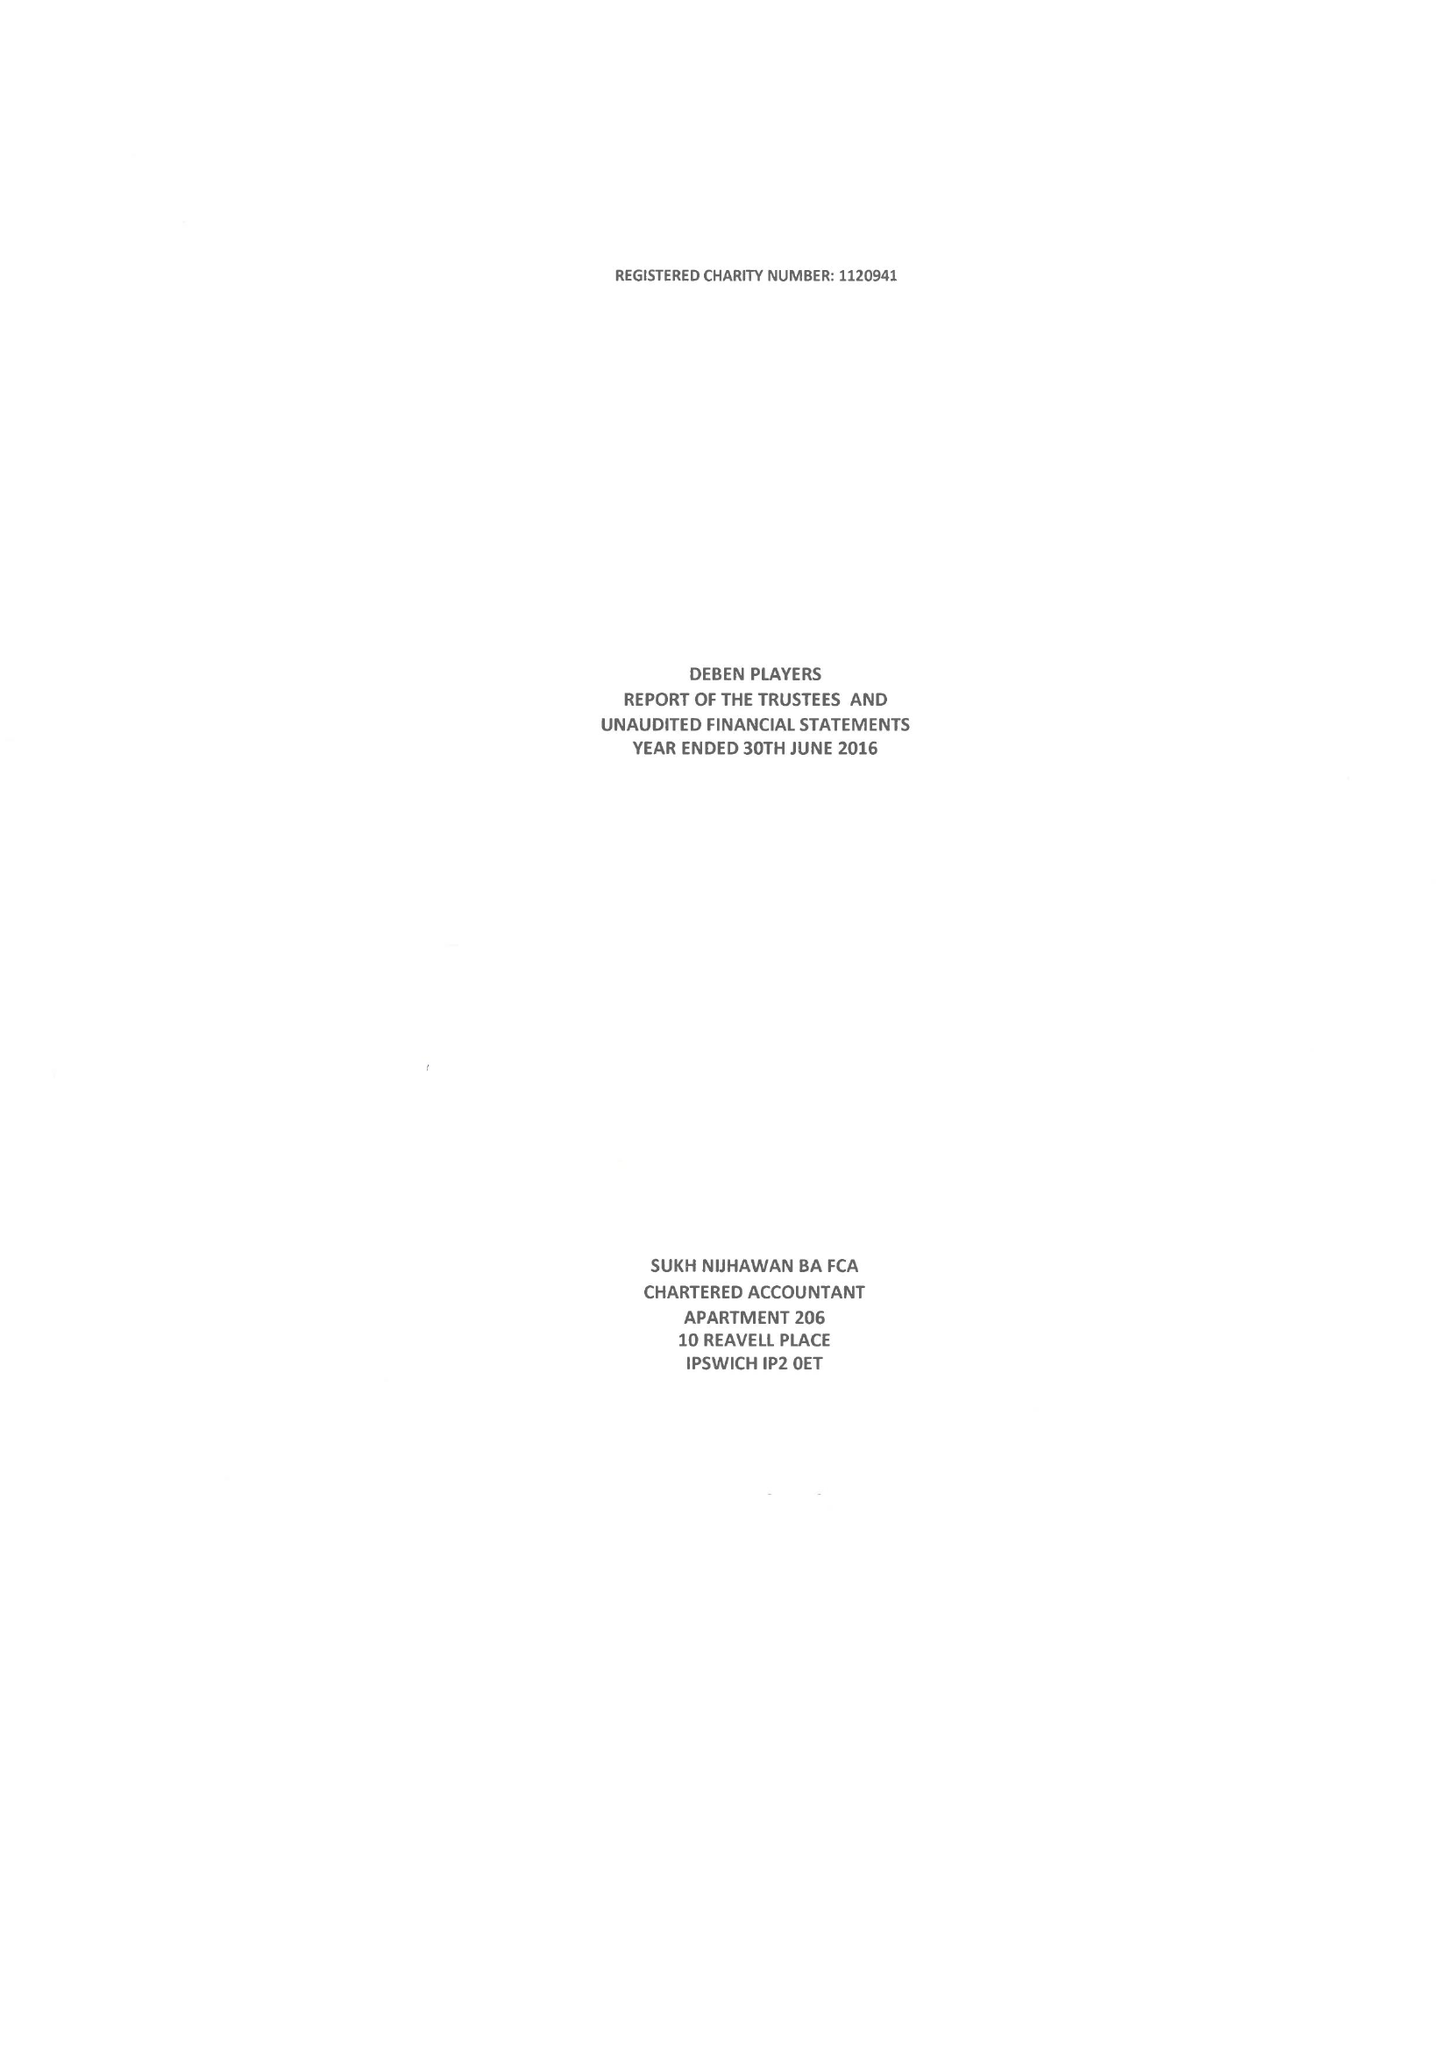What is the value for the income_annually_in_british_pounds?
Answer the question using a single word or phrase. 27445.00 